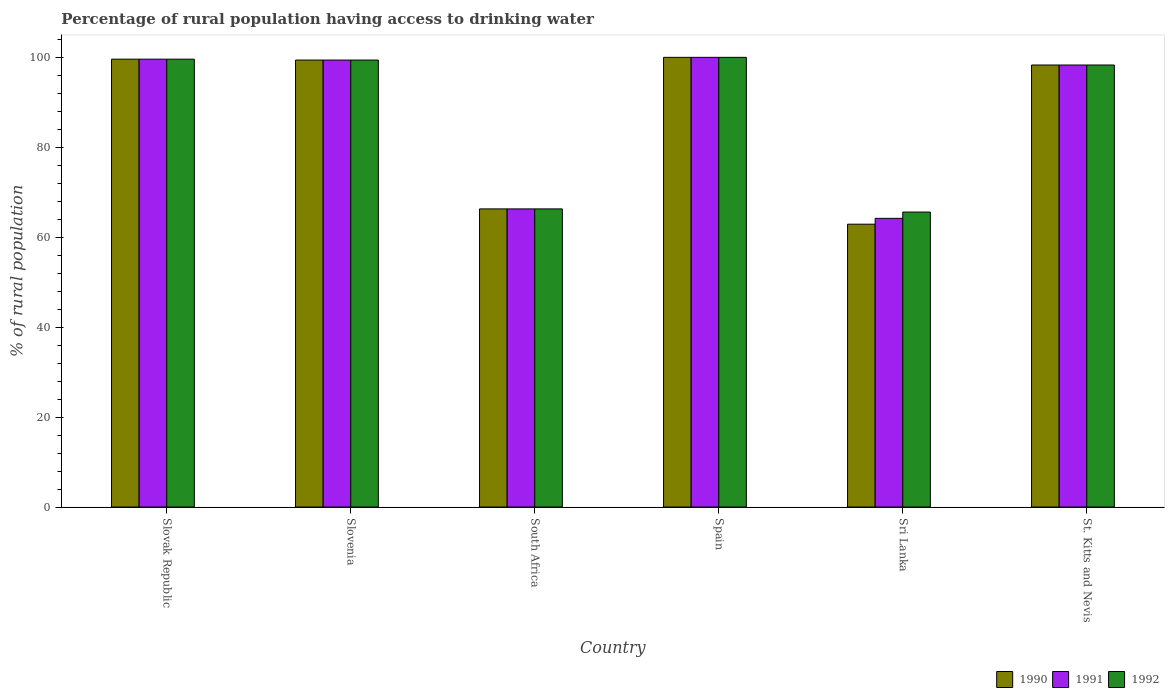How many groups of bars are there?
Your answer should be very brief. 6. Are the number of bars on each tick of the X-axis equal?
Keep it short and to the point. Yes. How many bars are there on the 5th tick from the left?
Ensure brevity in your answer.  3. In how many cases, is the number of bars for a given country not equal to the number of legend labels?
Offer a terse response. 0. What is the percentage of rural population having access to drinking water in 1991 in Slovenia?
Your answer should be compact. 99.4. Across all countries, what is the minimum percentage of rural population having access to drinking water in 1991?
Provide a short and direct response. 64.2. In which country was the percentage of rural population having access to drinking water in 1992 maximum?
Make the answer very short. Spain. In which country was the percentage of rural population having access to drinking water in 1992 minimum?
Your response must be concise. Sri Lanka. What is the total percentage of rural population having access to drinking water in 1990 in the graph?
Your answer should be compact. 526.5. What is the difference between the percentage of rural population having access to drinking water in 1991 in Slovak Republic and that in Slovenia?
Offer a terse response. 0.2. What is the difference between the percentage of rural population having access to drinking water in 1992 in Sri Lanka and the percentage of rural population having access to drinking water in 1990 in Slovak Republic?
Keep it short and to the point. -34. What is the average percentage of rural population having access to drinking water in 1992 per country?
Offer a very short reply. 88.2. What is the difference between the percentage of rural population having access to drinking water of/in 1990 and percentage of rural population having access to drinking water of/in 1992 in Slovenia?
Offer a very short reply. 0. In how many countries, is the percentage of rural population having access to drinking water in 1990 greater than 4 %?
Give a very brief answer. 6. What is the ratio of the percentage of rural population having access to drinking water in 1992 in Slovak Republic to that in South Africa?
Keep it short and to the point. 1.5. What is the difference between the highest and the second highest percentage of rural population having access to drinking water in 1991?
Keep it short and to the point. -0.2. What is the difference between the highest and the lowest percentage of rural population having access to drinking water in 1992?
Offer a terse response. 34.4. Is the sum of the percentage of rural population having access to drinking water in 1990 in South Africa and St. Kitts and Nevis greater than the maximum percentage of rural population having access to drinking water in 1991 across all countries?
Offer a very short reply. Yes. What does the 1st bar from the left in Slovak Republic represents?
Your response must be concise. 1990. Is it the case that in every country, the sum of the percentage of rural population having access to drinking water in 1990 and percentage of rural population having access to drinking water in 1992 is greater than the percentage of rural population having access to drinking water in 1991?
Provide a short and direct response. Yes. Are all the bars in the graph horizontal?
Offer a very short reply. No. How many countries are there in the graph?
Keep it short and to the point. 6. What is the difference between two consecutive major ticks on the Y-axis?
Offer a terse response. 20. How many legend labels are there?
Your answer should be very brief. 3. What is the title of the graph?
Offer a very short reply. Percentage of rural population having access to drinking water. Does "1999" appear as one of the legend labels in the graph?
Keep it short and to the point. No. What is the label or title of the Y-axis?
Provide a short and direct response. % of rural population. What is the % of rural population of 1990 in Slovak Republic?
Keep it short and to the point. 99.6. What is the % of rural population in 1991 in Slovak Republic?
Provide a short and direct response. 99.6. What is the % of rural population of 1992 in Slovak Republic?
Offer a terse response. 99.6. What is the % of rural population in 1990 in Slovenia?
Your answer should be very brief. 99.4. What is the % of rural population of 1991 in Slovenia?
Ensure brevity in your answer.  99.4. What is the % of rural population in 1992 in Slovenia?
Your answer should be very brief. 99.4. What is the % of rural population in 1990 in South Africa?
Provide a short and direct response. 66.3. What is the % of rural population in 1991 in South Africa?
Provide a short and direct response. 66.3. What is the % of rural population in 1992 in South Africa?
Ensure brevity in your answer.  66.3. What is the % of rural population of 1990 in Sri Lanka?
Your answer should be very brief. 62.9. What is the % of rural population in 1991 in Sri Lanka?
Your response must be concise. 64.2. What is the % of rural population of 1992 in Sri Lanka?
Your answer should be very brief. 65.6. What is the % of rural population in 1990 in St. Kitts and Nevis?
Give a very brief answer. 98.3. What is the % of rural population in 1991 in St. Kitts and Nevis?
Ensure brevity in your answer.  98.3. What is the % of rural population of 1992 in St. Kitts and Nevis?
Make the answer very short. 98.3. Across all countries, what is the maximum % of rural population of 1992?
Ensure brevity in your answer.  100. Across all countries, what is the minimum % of rural population in 1990?
Keep it short and to the point. 62.9. Across all countries, what is the minimum % of rural population in 1991?
Make the answer very short. 64.2. Across all countries, what is the minimum % of rural population of 1992?
Provide a short and direct response. 65.6. What is the total % of rural population in 1990 in the graph?
Provide a succinct answer. 526.5. What is the total % of rural population of 1991 in the graph?
Your answer should be compact. 527.8. What is the total % of rural population of 1992 in the graph?
Provide a short and direct response. 529.2. What is the difference between the % of rural population of 1990 in Slovak Republic and that in Slovenia?
Provide a short and direct response. 0.2. What is the difference between the % of rural population in 1991 in Slovak Republic and that in Slovenia?
Offer a very short reply. 0.2. What is the difference between the % of rural population of 1990 in Slovak Republic and that in South Africa?
Give a very brief answer. 33.3. What is the difference between the % of rural population of 1991 in Slovak Republic and that in South Africa?
Offer a terse response. 33.3. What is the difference between the % of rural population in 1992 in Slovak Republic and that in South Africa?
Your answer should be very brief. 33.3. What is the difference between the % of rural population of 1990 in Slovak Republic and that in Sri Lanka?
Provide a short and direct response. 36.7. What is the difference between the % of rural population in 1991 in Slovak Republic and that in Sri Lanka?
Your answer should be very brief. 35.4. What is the difference between the % of rural population of 1992 in Slovak Republic and that in St. Kitts and Nevis?
Provide a short and direct response. 1.3. What is the difference between the % of rural population of 1990 in Slovenia and that in South Africa?
Your response must be concise. 33.1. What is the difference between the % of rural population of 1991 in Slovenia and that in South Africa?
Keep it short and to the point. 33.1. What is the difference between the % of rural population in 1992 in Slovenia and that in South Africa?
Provide a succinct answer. 33.1. What is the difference between the % of rural population of 1990 in Slovenia and that in Spain?
Make the answer very short. -0.6. What is the difference between the % of rural population of 1992 in Slovenia and that in Spain?
Keep it short and to the point. -0.6. What is the difference between the % of rural population in 1990 in Slovenia and that in Sri Lanka?
Ensure brevity in your answer.  36.5. What is the difference between the % of rural population in 1991 in Slovenia and that in Sri Lanka?
Keep it short and to the point. 35.2. What is the difference between the % of rural population in 1992 in Slovenia and that in Sri Lanka?
Give a very brief answer. 33.8. What is the difference between the % of rural population of 1990 in Slovenia and that in St. Kitts and Nevis?
Provide a succinct answer. 1.1. What is the difference between the % of rural population of 1992 in Slovenia and that in St. Kitts and Nevis?
Give a very brief answer. 1.1. What is the difference between the % of rural population in 1990 in South Africa and that in Spain?
Your answer should be compact. -33.7. What is the difference between the % of rural population of 1991 in South Africa and that in Spain?
Keep it short and to the point. -33.7. What is the difference between the % of rural population in 1992 in South Africa and that in Spain?
Your response must be concise. -33.7. What is the difference between the % of rural population of 1990 in South Africa and that in St. Kitts and Nevis?
Give a very brief answer. -32. What is the difference between the % of rural population of 1991 in South Africa and that in St. Kitts and Nevis?
Your answer should be very brief. -32. What is the difference between the % of rural population of 1992 in South Africa and that in St. Kitts and Nevis?
Provide a short and direct response. -32. What is the difference between the % of rural population in 1990 in Spain and that in Sri Lanka?
Give a very brief answer. 37.1. What is the difference between the % of rural population of 1991 in Spain and that in Sri Lanka?
Your answer should be very brief. 35.8. What is the difference between the % of rural population of 1992 in Spain and that in Sri Lanka?
Keep it short and to the point. 34.4. What is the difference between the % of rural population of 1990 in Spain and that in St. Kitts and Nevis?
Keep it short and to the point. 1.7. What is the difference between the % of rural population of 1992 in Spain and that in St. Kitts and Nevis?
Provide a short and direct response. 1.7. What is the difference between the % of rural population in 1990 in Sri Lanka and that in St. Kitts and Nevis?
Provide a succinct answer. -35.4. What is the difference between the % of rural population of 1991 in Sri Lanka and that in St. Kitts and Nevis?
Your response must be concise. -34.1. What is the difference between the % of rural population in 1992 in Sri Lanka and that in St. Kitts and Nevis?
Provide a short and direct response. -32.7. What is the difference between the % of rural population of 1990 in Slovak Republic and the % of rural population of 1991 in Slovenia?
Your answer should be very brief. 0.2. What is the difference between the % of rural population in 1990 in Slovak Republic and the % of rural population in 1992 in Slovenia?
Offer a very short reply. 0.2. What is the difference between the % of rural population in 1990 in Slovak Republic and the % of rural population in 1991 in South Africa?
Make the answer very short. 33.3. What is the difference between the % of rural population of 1990 in Slovak Republic and the % of rural population of 1992 in South Africa?
Give a very brief answer. 33.3. What is the difference between the % of rural population in 1991 in Slovak Republic and the % of rural population in 1992 in South Africa?
Make the answer very short. 33.3. What is the difference between the % of rural population in 1990 in Slovak Republic and the % of rural population in 1991 in Spain?
Ensure brevity in your answer.  -0.4. What is the difference between the % of rural population of 1990 in Slovak Republic and the % of rural population of 1991 in Sri Lanka?
Provide a short and direct response. 35.4. What is the difference between the % of rural population in 1990 in Slovak Republic and the % of rural population in 1991 in St. Kitts and Nevis?
Ensure brevity in your answer.  1.3. What is the difference between the % of rural population in 1991 in Slovak Republic and the % of rural population in 1992 in St. Kitts and Nevis?
Offer a terse response. 1.3. What is the difference between the % of rural population of 1990 in Slovenia and the % of rural population of 1991 in South Africa?
Offer a terse response. 33.1. What is the difference between the % of rural population in 1990 in Slovenia and the % of rural population in 1992 in South Africa?
Ensure brevity in your answer.  33.1. What is the difference between the % of rural population of 1991 in Slovenia and the % of rural population of 1992 in South Africa?
Your response must be concise. 33.1. What is the difference between the % of rural population in 1991 in Slovenia and the % of rural population in 1992 in Spain?
Offer a terse response. -0.6. What is the difference between the % of rural population of 1990 in Slovenia and the % of rural population of 1991 in Sri Lanka?
Offer a very short reply. 35.2. What is the difference between the % of rural population of 1990 in Slovenia and the % of rural population of 1992 in Sri Lanka?
Offer a terse response. 33.8. What is the difference between the % of rural population of 1991 in Slovenia and the % of rural population of 1992 in Sri Lanka?
Your answer should be compact. 33.8. What is the difference between the % of rural population in 1990 in South Africa and the % of rural population in 1991 in Spain?
Your response must be concise. -33.7. What is the difference between the % of rural population of 1990 in South Africa and the % of rural population of 1992 in Spain?
Your answer should be compact. -33.7. What is the difference between the % of rural population in 1991 in South Africa and the % of rural population in 1992 in Spain?
Give a very brief answer. -33.7. What is the difference between the % of rural population of 1990 in South Africa and the % of rural population of 1991 in Sri Lanka?
Give a very brief answer. 2.1. What is the difference between the % of rural population of 1990 in South Africa and the % of rural population of 1992 in Sri Lanka?
Ensure brevity in your answer.  0.7. What is the difference between the % of rural population in 1990 in South Africa and the % of rural population in 1991 in St. Kitts and Nevis?
Make the answer very short. -32. What is the difference between the % of rural population in 1990 in South Africa and the % of rural population in 1992 in St. Kitts and Nevis?
Your answer should be compact. -32. What is the difference between the % of rural population in 1991 in South Africa and the % of rural population in 1992 in St. Kitts and Nevis?
Provide a succinct answer. -32. What is the difference between the % of rural population of 1990 in Spain and the % of rural population of 1991 in Sri Lanka?
Provide a short and direct response. 35.8. What is the difference between the % of rural population in 1990 in Spain and the % of rural population in 1992 in Sri Lanka?
Provide a short and direct response. 34.4. What is the difference between the % of rural population of 1991 in Spain and the % of rural population of 1992 in Sri Lanka?
Your answer should be very brief. 34.4. What is the difference between the % of rural population in 1991 in Spain and the % of rural population in 1992 in St. Kitts and Nevis?
Your answer should be compact. 1.7. What is the difference between the % of rural population in 1990 in Sri Lanka and the % of rural population in 1991 in St. Kitts and Nevis?
Make the answer very short. -35.4. What is the difference between the % of rural population of 1990 in Sri Lanka and the % of rural population of 1992 in St. Kitts and Nevis?
Your answer should be compact. -35.4. What is the difference between the % of rural population in 1991 in Sri Lanka and the % of rural population in 1992 in St. Kitts and Nevis?
Offer a terse response. -34.1. What is the average % of rural population in 1990 per country?
Make the answer very short. 87.75. What is the average % of rural population of 1991 per country?
Give a very brief answer. 87.97. What is the average % of rural population of 1992 per country?
Your answer should be compact. 88.2. What is the difference between the % of rural population in 1990 and % of rural population in 1992 in Slovenia?
Your answer should be compact. 0. What is the difference between the % of rural population of 1991 and % of rural population of 1992 in South Africa?
Provide a succinct answer. 0. What is the difference between the % of rural population of 1990 and % of rural population of 1991 in Spain?
Your answer should be very brief. 0. What is the difference between the % of rural population of 1991 and % of rural population of 1992 in Sri Lanka?
Your response must be concise. -1.4. What is the difference between the % of rural population of 1990 and % of rural population of 1991 in St. Kitts and Nevis?
Provide a succinct answer. 0. What is the difference between the % of rural population of 1991 and % of rural population of 1992 in St. Kitts and Nevis?
Your answer should be very brief. 0. What is the ratio of the % of rural population of 1992 in Slovak Republic to that in Slovenia?
Your response must be concise. 1. What is the ratio of the % of rural population in 1990 in Slovak Republic to that in South Africa?
Your answer should be very brief. 1.5. What is the ratio of the % of rural population of 1991 in Slovak Republic to that in South Africa?
Your answer should be compact. 1.5. What is the ratio of the % of rural population of 1992 in Slovak Republic to that in South Africa?
Ensure brevity in your answer.  1.5. What is the ratio of the % of rural population in 1992 in Slovak Republic to that in Spain?
Provide a succinct answer. 1. What is the ratio of the % of rural population in 1990 in Slovak Republic to that in Sri Lanka?
Offer a very short reply. 1.58. What is the ratio of the % of rural population of 1991 in Slovak Republic to that in Sri Lanka?
Ensure brevity in your answer.  1.55. What is the ratio of the % of rural population in 1992 in Slovak Republic to that in Sri Lanka?
Your answer should be very brief. 1.52. What is the ratio of the % of rural population in 1990 in Slovak Republic to that in St. Kitts and Nevis?
Ensure brevity in your answer.  1.01. What is the ratio of the % of rural population of 1991 in Slovak Republic to that in St. Kitts and Nevis?
Provide a short and direct response. 1.01. What is the ratio of the % of rural population of 1992 in Slovak Republic to that in St. Kitts and Nevis?
Make the answer very short. 1.01. What is the ratio of the % of rural population in 1990 in Slovenia to that in South Africa?
Your response must be concise. 1.5. What is the ratio of the % of rural population of 1991 in Slovenia to that in South Africa?
Keep it short and to the point. 1.5. What is the ratio of the % of rural population of 1992 in Slovenia to that in South Africa?
Offer a terse response. 1.5. What is the ratio of the % of rural population in 1990 in Slovenia to that in Spain?
Your answer should be compact. 0.99. What is the ratio of the % of rural population in 1991 in Slovenia to that in Spain?
Provide a short and direct response. 0.99. What is the ratio of the % of rural population of 1990 in Slovenia to that in Sri Lanka?
Provide a short and direct response. 1.58. What is the ratio of the % of rural population of 1991 in Slovenia to that in Sri Lanka?
Your response must be concise. 1.55. What is the ratio of the % of rural population of 1992 in Slovenia to that in Sri Lanka?
Your response must be concise. 1.52. What is the ratio of the % of rural population of 1990 in Slovenia to that in St. Kitts and Nevis?
Offer a very short reply. 1.01. What is the ratio of the % of rural population of 1991 in Slovenia to that in St. Kitts and Nevis?
Your response must be concise. 1.01. What is the ratio of the % of rural population of 1992 in Slovenia to that in St. Kitts and Nevis?
Your answer should be compact. 1.01. What is the ratio of the % of rural population in 1990 in South Africa to that in Spain?
Ensure brevity in your answer.  0.66. What is the ratio of the % of rural population in 1991 in South Africa to that in Spain?
Your response must be concise. 0.66. What is the ratio of the % of rural population of 1992 in South Africa to that in Spain?
Your answer should be very brief. 0.66. What is the ratio of the % of rural population in 1990 in South Africa to that in Sri Lanka?
Your answer should be compact. 1.05. What is the ratio of the % of rural population of 1991 in South Africa to that in Sri Lanka?
Give a very brief answer. 1.03. What is the ratio of the % of rural population of 1992 in South Africa to that in Sri Lanka?
Provide a short and direct response. 1.01. What is the ratio of the % of rural population in 1990 in South Africa to that in St. Kitts and Nevis?
Provide a succinct answer. 0.67. What is the ratio of the % of rural population of 1991 in South Africa to that in St. Kitts and Nevis?
Ensure brevity in your answer.  0.67. What is the ratio of the % of rural population in 1992 in South Africa to that in St. Kitts and Nevis?
Provide a short and direct response. 0.67. What is the ratio of the % of rural population in 1990 in Spain to that in Sri Lanka?
Ensure brevity in your answer.  1.59. What is the ratio of the % of rural population of 1991 in Spain to that in Sri Lanka?
Make the answer very short. 1.56. What is the ratio of the % of rural population of 1992 in Spain to that in Sri Lanka?
Keep it short and to the point. 1.52. What is the ratio of the % of rural population of 1990 in Spain to that in St. Kitts and Nevis?
Make the answer very short. 1.02. What is the ratio of the % of rural population of 1991 in Spain to that in St. Kitts and Nevis?
Your answer should be compact. 1.02. What is the ratio of the % of rural population in 1992 in Spain to that in St. Kitts and Nevis?
Provide a short and direct response. 1.02. What is the ratio of the % of rural population of 1990 in Sri Lanka to that in St. Kitts and Nevis?
Your answer should be compact. 0.64. What is the ratio of the % of rural population of 1991 in Sri Lanka to that in St. Kitts and Nevis?
Provide a short and direct response. 0.65. What is the ratio of the % of rural population of 1992 in Sri Lanka to that in St. Kitts and Nevis?
Offer a very short reply. 0.67. What is the difference between the highest and the second highest % of rural population in 1990?
Ensure brevity in your answer.  0.4. What is the difference between the highest and the second highest % of rural population in 1991?
Ensure brevity in your answer.  0.4. What is the difference between the highest and the second highest % of rural population in 1992?
Give a very brief answer. 0.4. What is the difference between the highest and the lowest % of rural population of 1990?
Ensure brevity in your answer.  37.1. What is the difference between the highest and the lowest % of rural population in 1991?
Ensure brevity in your answer.  35.8. What is the difference between the highest and the lowest % of rural population of 1992?
Ensure brevity in your answer.  34.4. 